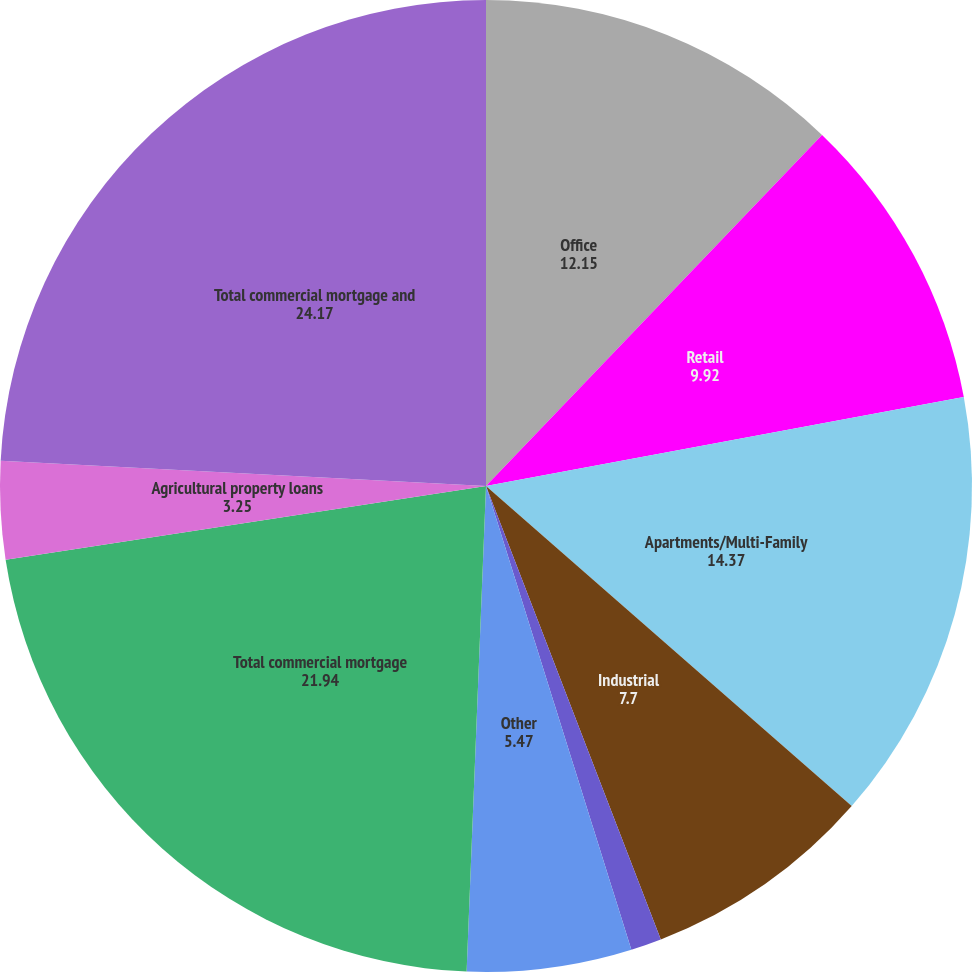<chart> <loc_0><loc_0><loc_500><loc_500><pie_chart><fcel>Office<fcel>Retail<fcel>Apartments/Multi-Family<fcel>Industrial<fcel>Hospitality<fcel>Other<fcel>Total commercial mortgage<fcel>Agricultural property loans<fcel>Total commercial mortgage and<nl><fcel>12.15%<fcel>9.92%<fcel>14.37%<fcel>7.7%<fcel>1.02%<fcel>5.47%<fcel>21.94%<fcel>3.25%<fcel>24.17%<nl></chart> 